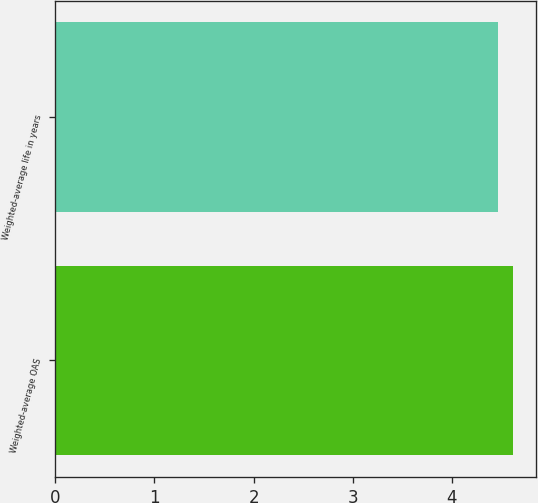Convert chart to OTSL. <chart><loc_0><loc_0><loc_500><loc_500><bar_chart><fcel>Weighted-average OAS<fcel>Weighted-average life in years<nl><fcel>4.62<fcel>4.46<nl></chart> 